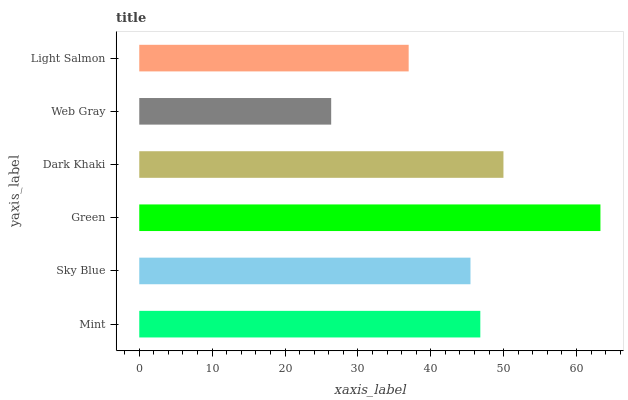Is Web Gray the minimum?
Answer yes or no. Yes. Is Green the maximum?
Answer yes or no. Yes. Is Sky Blue the minimum?
Answer yes or no. No. Is Sky Blue the maximum?
Answer yes or no. No. Is Mint greater than Sky Blue?
Answer yes or no. Yes. Is Sky Blue less than Mint?
Answer yes or no. Yes. Is Sky Blue greater than Mint?
Answer yes or no. No. Is Mint less than Sky Blue?
Answer yes or no. No. Is Mint the high median?
Answer yes or no. Yes. Is Sky Blue the low median?
Answer yes or no. Yes. Is Sky Blue the high median?
Answer yes or no. No. Is Web Gray the low median?
Answer yes or no. No. 